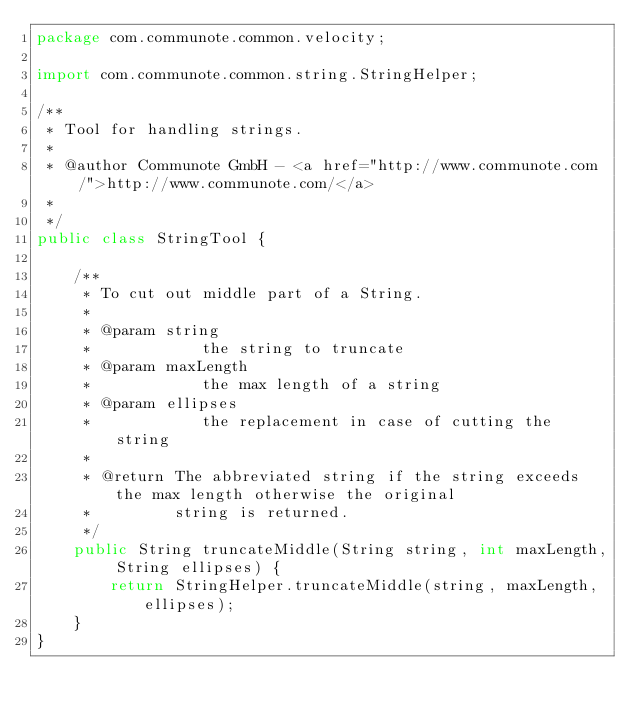<code> <loc_0><loc_0><loc_500><loc_500><_Java_>package com.communote.common.velocity;

import com.communote.common.string.StringHelper;

/**
 * Tool for handling strings.
 * 
 * @author Communote GmbH - <a href="http://www.communote.com/">http://www.communote.com/</a>
 * 
 */
public class StringTool {

    /**
     * To cut out middle part of a String.
     * 
     * @param string
     *            the string to truncate
     * @param maxLength
     *            the max length of a string
     * @param ellipses
     *            the replacement in case of cutting the string
     * 
     * @return The abbreviated string if the string exceeds the max length otherwise the original
     *         string is returned.
     */
    public String truncateMiddle(String string, int maxLength, String ellipses) {
        return StringHelper.truncateMiddle(string, maxLength, ellipses);
    }
}
</code> 